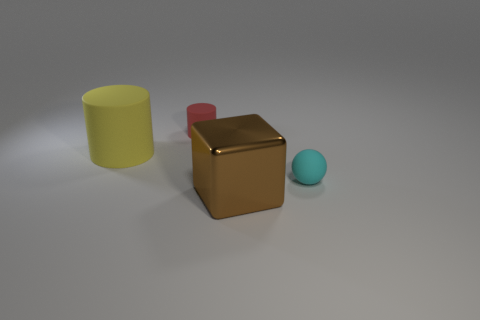How big is the thing in front of the rubber object on the right side of the cylinder on the right side of the big yellow rubber cylinder?
Your answer should be very brief. Large. Is the size of the cylinder in front of the small rubber cylinder the same as the cylinder that is on the right side of the yellow thing?
Your answer should be compact. No. Is the small red object the same shape as the big matte object?
Your response must be concise. Yes. How many red cylinders are the same size as the shiny block?
Give a very brief answer. 0. Are there fewer big metallic objects behind the yellow matte thing than large red shiny cylinders?
Make the answer very short. No. There is a rubber object on the right side of the large object that is on the right side of the small red cylinder; what is its size?
Make the answer very short. Small. How many objects are big metallic blocks or tiny purple cylinders?
Your response must be concise. 1. Is the number of tiny red things less than the number of small cyan rubber cubes?
Provide a short and direct response. No. How many objects are red cylinders or small things to the left of the brown cube?
Your answer should be very brief. 1. Are there any large green blocks that have the same material as the tiny red thing?
Provide a succinct answer. No. 